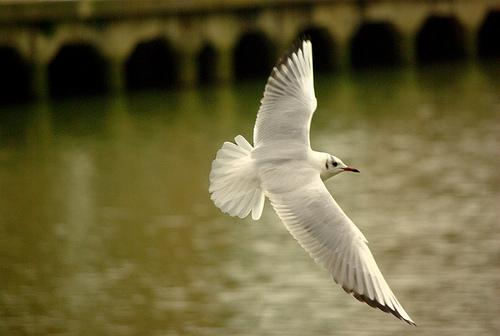What type of body of water is the bird flying over and describe what is above it. The bird is flying over a green-colored river with a bridge above it. What question could you ask about the presence of black holes in the image? There are no black holes visible in the image. Could you clarify what you are referring to? What kind of advertisement can you create by using the visual elements in the image? "Experience the freedom of flight with our advanced drone technology - capture the elegance of a white bird soaring above green rivers and stunning landscapes." Imagine you are describing the image to someone who cannot see it. Mention the bird, water, and background. A beautiful white bird is flying over a green-colored river. The background features a bridge above the water. List the adjectives that describe the bird in the image. White, flying, with a red beak and black tips on wings. Predict the next course of action the bird might take based on its position in the image. The bird may continue to fly towards the left side of the image, possibly exploring the area under the bridge or soaring above it. How would you describe the bird's beak colors and the tip of its wings? The bird's beak is red, and the tips of its wings are black. Mention the primary action the bird is performing and its physical features. The bird is flying, has a white body, black eye, red beak, and black wingtips. Describe the background of the image in terms of color and objects. The background features a green river and a bridge above it. 